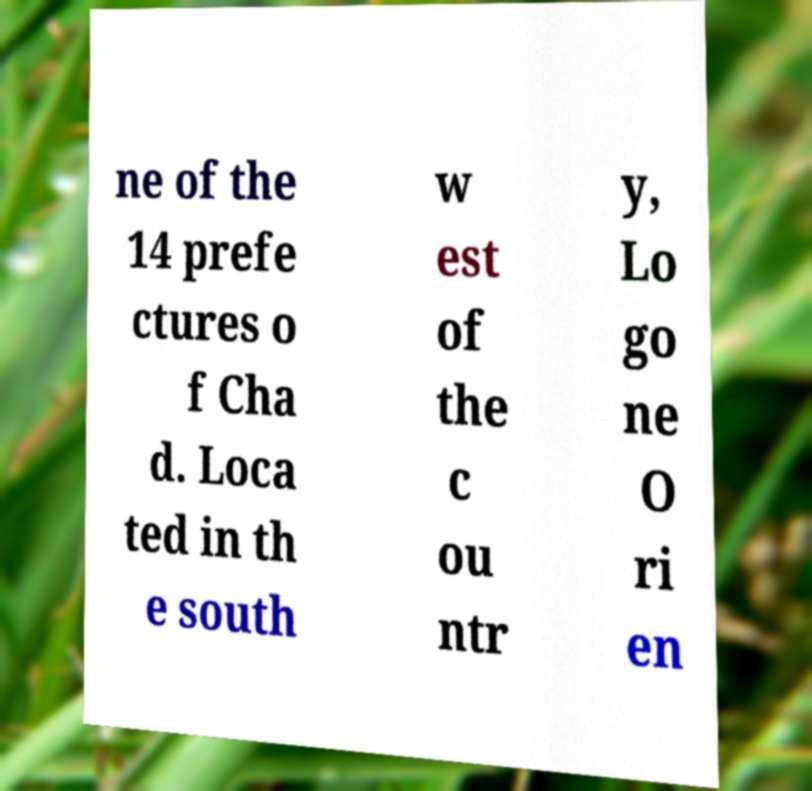Can you read and provide the text displayed in the image?This photo seems to have some interesting text. Can you extract and type it out for me? ne of the 14 prefe ctures o f Cha d. Loca ted in th e south w est of the c ou ntr y, Lo go ne O ri en 